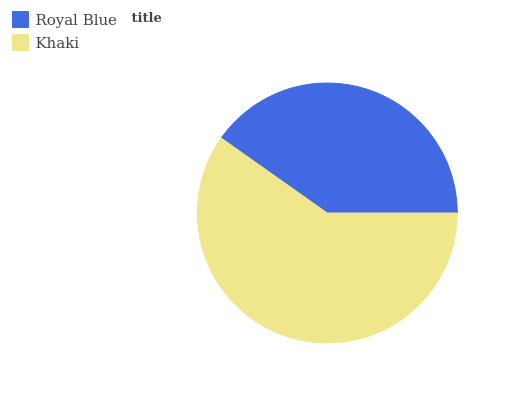Is Royal Blue the minimum?
Answer yes or no. Yes. Is Khaki the maximum?
Answer yes or no. Yes. Is Khaki the minimum?
Answer yes or no. No. Is Khaki greater than Royal Blue?
Answer yes or no. Yes. Is Royal Blue less than Khaki?
Answer yes or no. Yes. Is Royal Blue greater than Khaki?
Answer yes or no. No. Is Khaki less than Royal Blue?
Answer yes or no. No. Is Khaki the high median?
Answer yes or no. Yes. Is Royal Blue the low median?
Answer yes or no. Yes. Is Royal Blue the high median?
Answer yes or no. No. Is Khaki the low median?
Answer yes or no. No. 